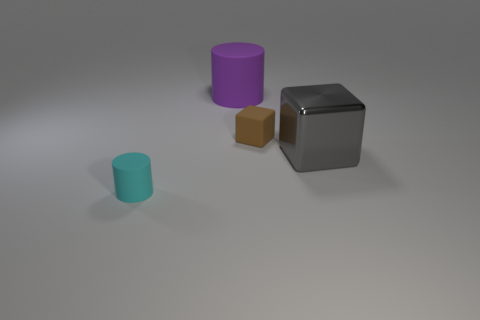What number of other things are the same size as the rubber cube? 1 